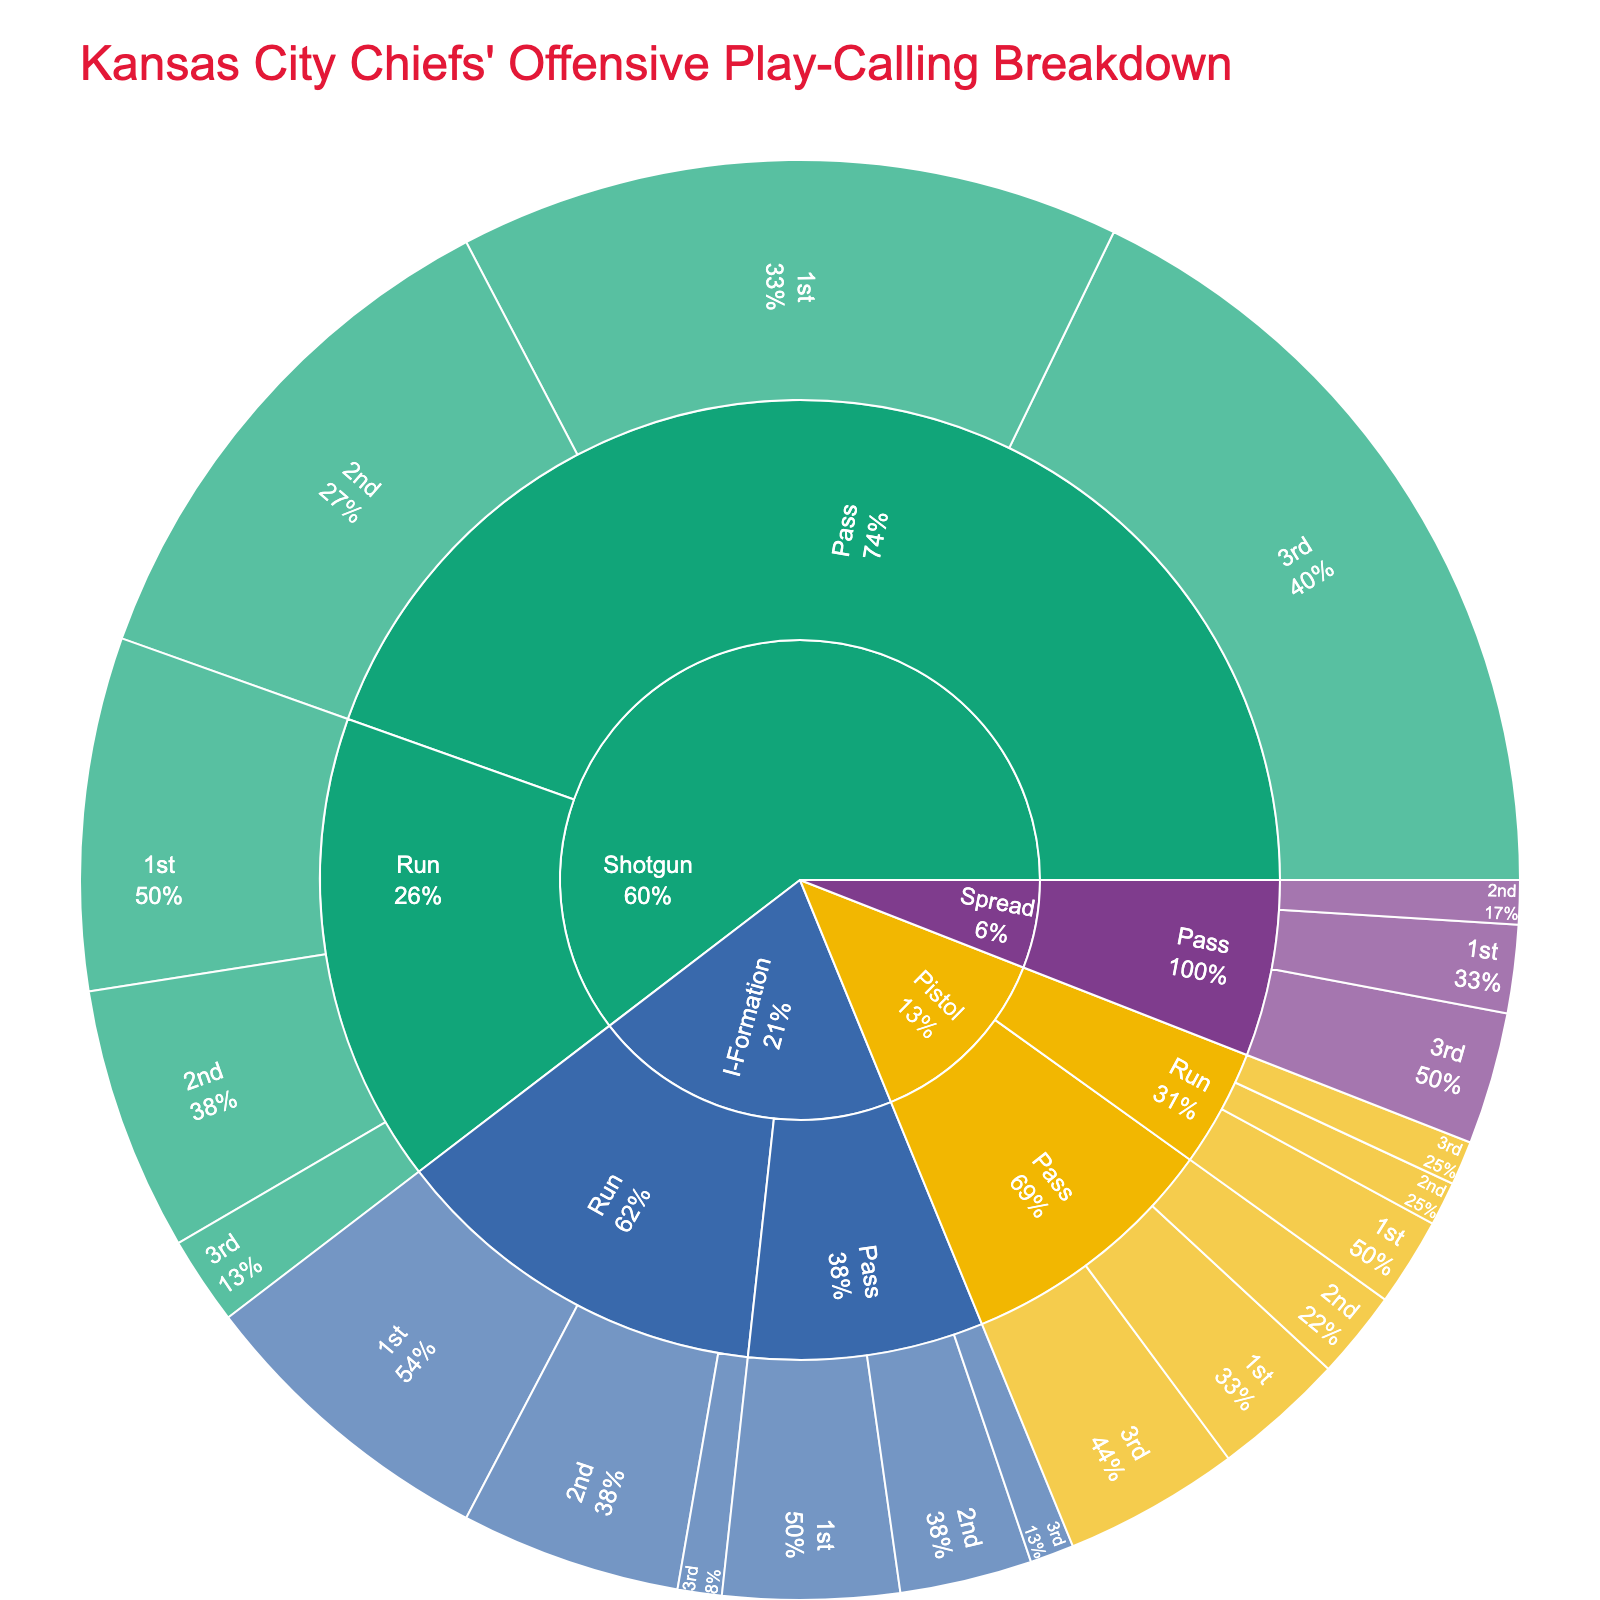Which formation is used the most overall? Look for the largest section in the sunburst plot. The Shotgun formation has the highest overall percentage compared to I-Formation, Pistol, and Spread.
Answer: Shotgun Which play type is used more frequently on the 1st down in the Shotgun formation, passing or running? In the Shotgun formation on 1st down, passing has a larger portion (15%) compared to running (8%).
Answer: Passing What percentage of plays are passing plays on the 3rd down? Sum up the percentages of passing plays on the 3rd down across all formations: Shotgun (18%), I-Formation (1%), Pistol (4%), and Spread (3%). 18 + 1 + 4 + 3 = 26%
Answer: 26% Which formation has a higher percentage of running plays on the 2nd down, Shotgun or I-Formation? Compare the percentages: Shotgun (6%) and I-Formation (5%). The Shotgun formation has a slightly higher percentage.
Answer: Shotgun How does the usage of the Pistol formation on the 1st down for running plays compare to the Shotgun formation? Compare the 1st down running percentages in Pistol (2%) and Shotgun (8%). The Shotgun formation is used more frequently for running on the 1st down.
Answer: Shotgun What is the percentage of running plays on the 3rd down for all formations combined? Sum up the percentages of running plays on the 3rd down for all formations: Shotgun (2%), I-Formation (1%), and Pistol (1%). 2 + 1 + 1 = 4%
Answer: 4% In which formation is passing used less on the 2nd down as compared to the 3rd down? Look at the percentages for passing on the 2nd and 3rd downs: Compare I-Formation (2nd: 3%, 3rd: 1%), Shotgun (2nd: 12%, 3rd: 18%), Pistol (2nd: 2%, 3rd: 4%), Spread (2nd: 1%, 3rd: 3%). Only I-Formation has a higher percentage on the 2nd down and lower on the 3rd down.
Answer: I-Formation Which formation and play type combination have the lowest usage on the 3rd down? Look for the smallest percentage on the 3rd down: I-Formation running (1%).
Answer: I-Formation running 